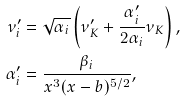Convert formula to latex. <formula><loc_0><loc_0><loc_500><loc_500>\nu _ { i } ^ { \prime } & = \sqrt { \alpha _ { i } } \left ( \nu _ { K } ^ { \prime } + \frac { \alpha _ { i } ^ { \prime } } { 2 \alpha _ { i } } \nu _ { K } \right ) , \\ \alpha _ { i } ^ { \prime } & = \frac { \beta _ { i } } { x ^ { 3 } ( x - b ) ^ { 5 / 2 } } ,</formula> 